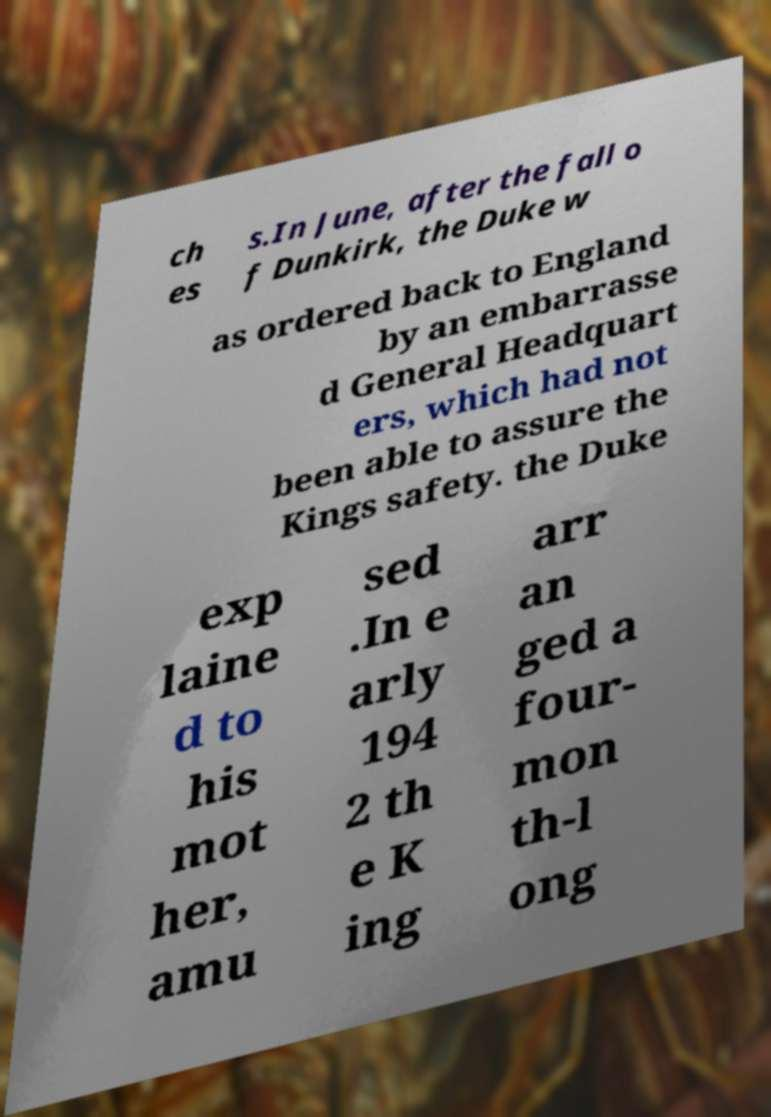Can you read and provide the text displayed in the image?This photo seems to have some interesting text. Can you extract and type it out for me? ch es s.In June, after the fall o f Dunkirk, the Duke w as ordered back to England by an embarrasse d General Headquart ers, which had not been able to assure the Kings safety. the Duke exp laine d to his mot her, amu sed .In e arly 194 2 th e K ing arr an ged a four- mon th-l ong 